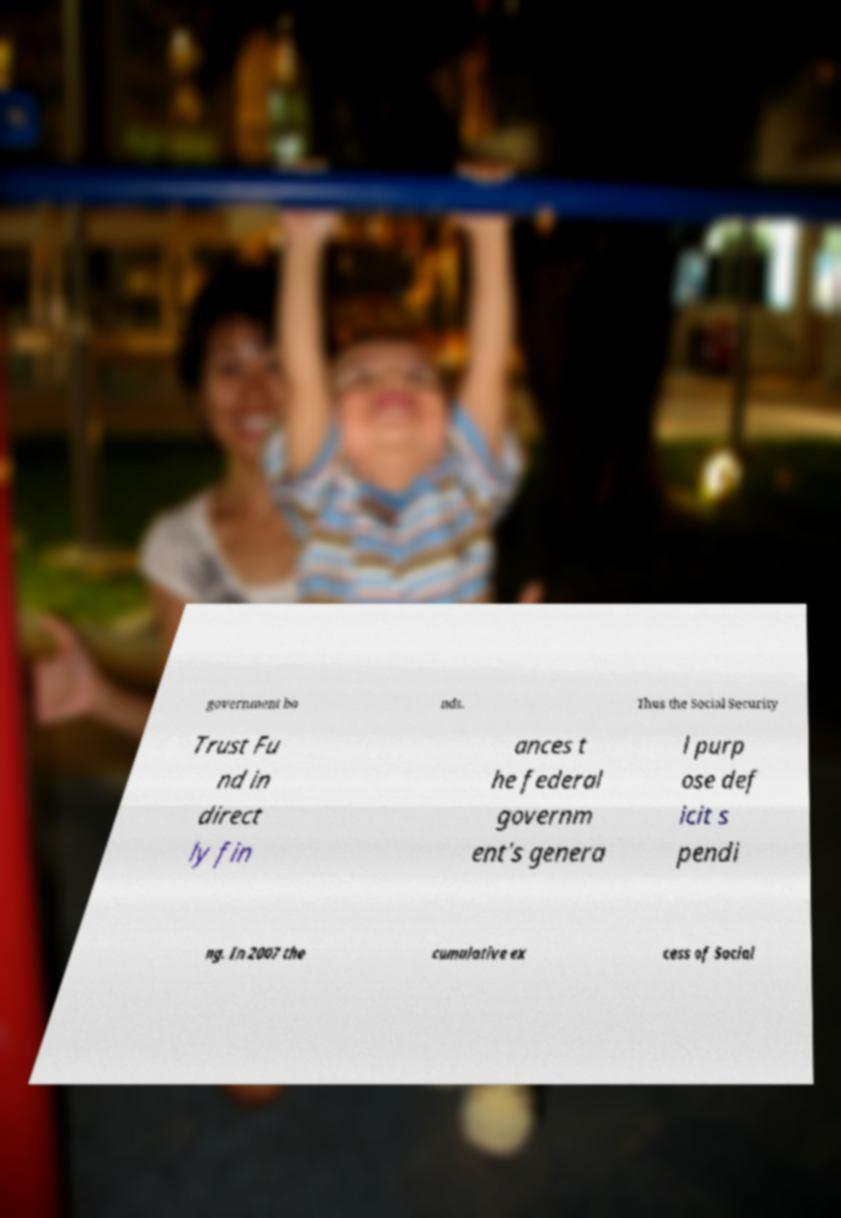Please read and relay the text visible in this image. What does it say? government bo nds. Thus the Social Security Trust Fu nd in direct ly fin ances t he federal governm ent's genera l purp ose def icit s pendi ng. In 2007 the cumulative ex cess of Social 